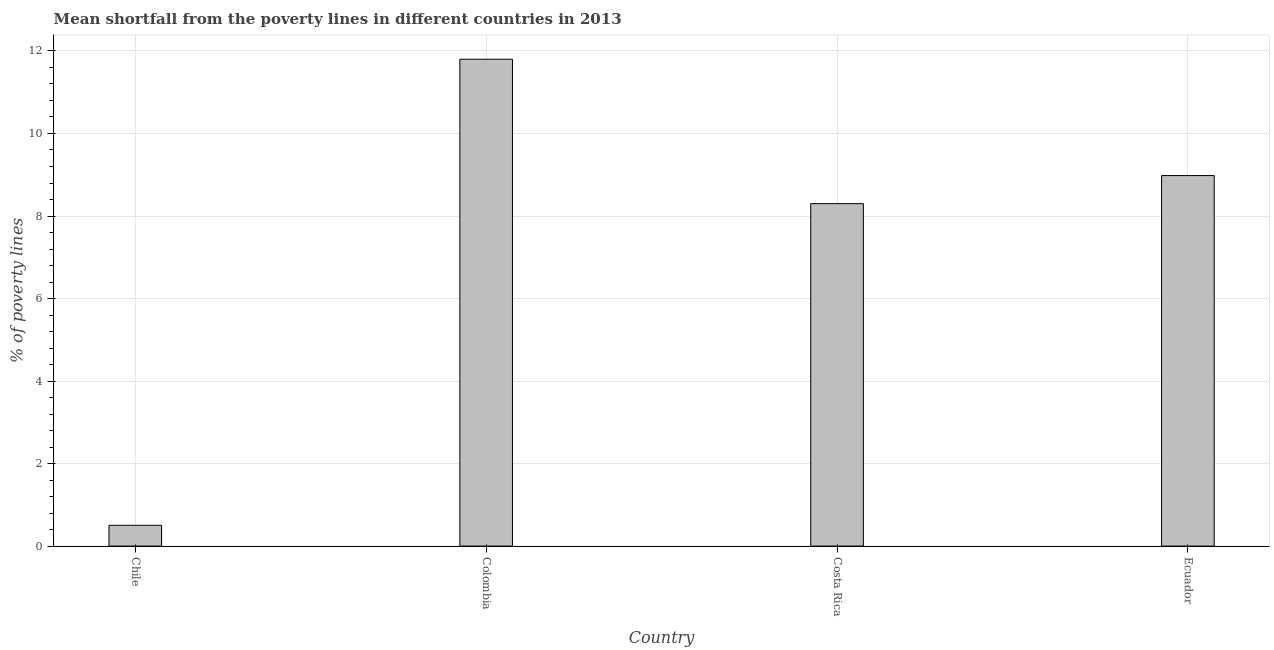What is the title of the graph?
Keep it short and to the point. Mean shortfall from the poverty lines in different countries in 2013. What is the label or title of the Y-axis?
Ensure brevity in your answer.  % of poverty lines. What is the poverty gap at national poverty lines in Chile?
Your response must be concise. 0.5. Across all countries, what is the minimum poverty gap at national poverty lines?
Your answer should be very brief. 0.5. In which country was the poverty gap at national poverty lines maximum?
Your answer should be very brief. Colombia. In which country was the poverty gap at national poverty lines minimum?
Provide a succinct answer. Chile. What is the sum of the poverty gap at national poverty lines?
Give a very brief answer. 29.58. What is the difference between the poverty gap at national poverty lines in Colombia and Costa Rica?
Keep it short and to the point. 3.5. What is the average poverty gap at national poverty lines per country?
Give a very brief answer. 7.4. What is the median poverty gap at national poverty lines?
Give a very brief answer. 8.64. What is the ratio of the poverty gap at national poverty lines in Chile to that in Costa Rica?
Provide a succinct answer. 0.06. Is the poverty gap at national poverty lines in Colombia less than that in Ecuador?
Offer a very short reply. No. What is the difference between the highest and the second highest poverty gap at national poverty lines?
Provide a succinct answer. 2.82. Is the sum of the poverty gap at national poverty lines in Chile and Ecuador greater than the maximum poverty gap at national poverty lines across all countries?
Keep it short and to the point. No. What is the difference between the highest and the lowest poverty gap at national poverty lines?
Keep it short and to the point. 11.3. How many bars are there?
Keep it short and to the point. 4. Are all the bars in the graph horizontal?
Make the answer very short. No. How many countries are there in the graph?
Ensure brevity in your answer.  4. What is the difference between two consecutive major ticks on the Y-axis?
Provide a short and direct response. 2. Are the values on the major ticks of Y-axis written in scientific E-notation?
Offer a very short reply. No. What is the % of poverty lines of Chile?
Provide a short and direct response. 0.5. What is the % of poverty lines in Colombia?
Provide a short and direct response. 11.8. What is the % of poverty lines of Ecuador?
Offer a terse response. 8.98. What is the difference between the % of poverty lines in Chile and Colombia?
Your answer should be very brief. -11.3. What is the difference between the % of poverty lines in Chile and Costa Rica?
Provide a succinct answer. -7.8. What is the difference between the % of poverty lines in Chile and Ecuador?
Provide a succinct answer. -8.48. What is the difference between the % of poverty lines in Colombia and Costa Rica?
Provide a short and direct response. 3.5. What is the difference between the % of poverty lines in Colombia and Ecuador?
Ensure brevity in your answer.  2.82. What is the difference between the % of poverty lines in Costa Rica and Ecuador?
Your answer should be compact. -0.68. What is the ratio of the % of poverty lines in Chile to that in Colombia?
Your answer should be compact. 0.04. What is the ratio of the % of poverty lines in Chile to that in Costa Rica?
Your response must be concise. 0.06. What is the ratio of the % of poverty lines in Chile to that in Ecuador?
Give a very brief answer. 0.06. What is the ratio of the % of poverty lines in Colombia to that in Costa Rica?
Provide a short and direct response. 1.42. What is the ratio of the % of poverty lines in Colombia to that in Ecuador?
Offer a terse response. 1.31. What is the ratio of the % of poverty lines in Costa Rica to that in Ecuador?
Offer a terse response. 0.92. 